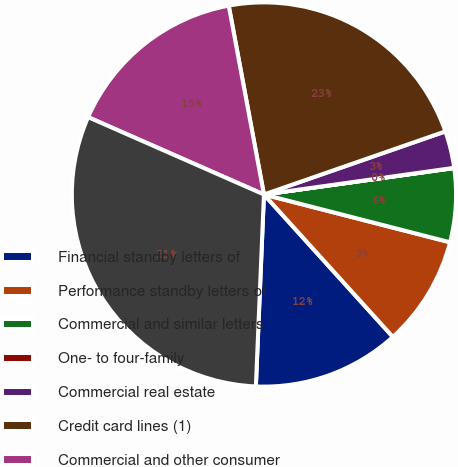Convert chart. <chart><loc_0><loc_0><loc_500><loc_500><pie_chart><fcel>Financial standby letters of<fcel>Performance standby letters of<fcel>Commercial and similar letters<fcel>One- to four-family<fcel>Commercial real estate<fcel>Credit card lines (1)<fcel>Commercial and other consumer<fcel>Total<nl><fcel>12.38%<fcel>9.29%<fcel>6.2%<fcel>0.02%<fcel>3.11%<fcel>22.61%<fcel>15.47%<fcel>30.93%<nl></chart> 